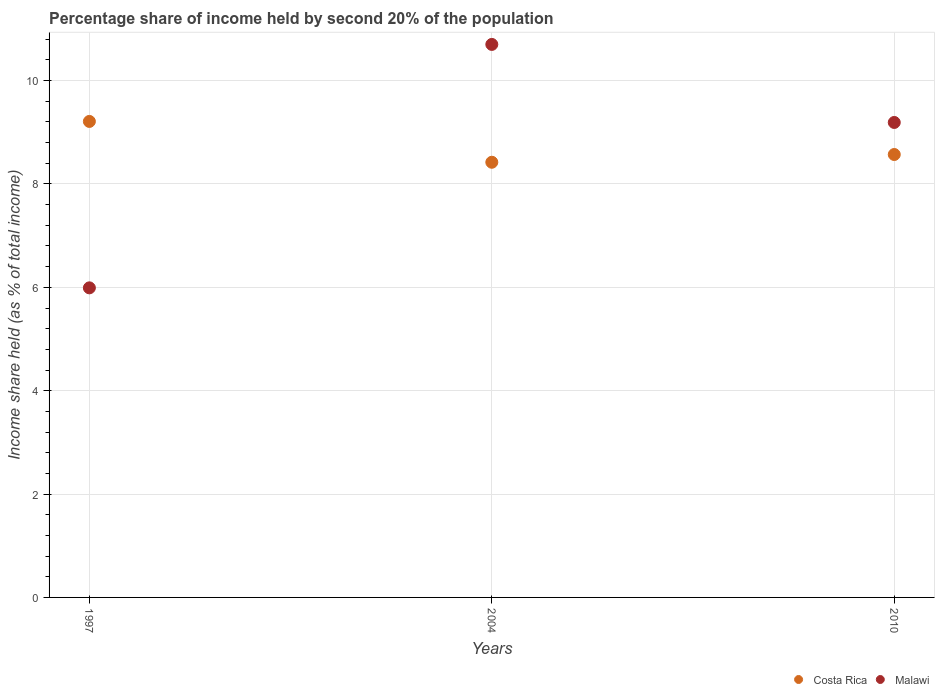Is the number of dotlines equal to the number of legend labels?
Make the answer very short. Yes. What is the share of income held by second 20% of the population in Malawi in 2010?
Give a very brief answer. 9.19. Across all years, what is the minimum share of income held by second 20% of the population in Malawi?
Offer a terse response. 5.99. What is the total share of income held by second 20% of the population in Malawi in the graph?
Give a very brief answer. 25.88. What is the difference between the share of income held by second 20% of the population in Malawi in 2004 and that in 2010?
Your response must be concise. 1.51. What is the difference between the share of income held by second 20% of the population in Malawi in 2004 and the share of income held by second 20% of the population in Costa Rica in 1997?
Your answer should be very brief. 1.49. What is the average share of income held by second 20% of the population in Malawi per year?
Provide a succinct answer. 8.63. In the year 1997, what is the difference between the share of income held by second 20% of the population in Costa Rica and share of income held by second 20% of the population in Malawi?
Provide a short and direct response. 3.22. What is the ratio of the share of income held by second 20% of the population in Costa Rica in 1997 to that in 2010?
Ensure brevity in your answer.  1.07. Is the share of income held by second 20% of the population in Malawi in 1997 less than that in 2010?
Give a very brief answer. Yes. Is the difference between the share of income held by second 20% of the population in Costa Rica in 2004 and 2010 greater than the difference between the share of income held by second 20% of the population in Malawi in 2004 and 2010?
Keep it short and to the point. No. What is the difference between the highest and the second highest share of income held by second 20% of the population in Malawi?
Your response must be concise. 1.51. What is the difference between the highest and the lowest share of income held by second 20% of the population in Costa Rica?
Ensure brevity in your answer.  0.79. Is the share of income held by second 20% of the population in Costa Rica strictly greater than the share of income held by second 20% of the population in Malawi over the years?
Make the answer very short. No. How many years are there in the graph?
Your response must be concise. 3. What is the difference between two consecutive major ticks on the Y-axis?
Keep it short and to the point. 2. Does the graph contain grids?
Offer a very short reply. Yes. Where does the legend appear in the graph?
Ensure brevity in your answer.  Bottom right. How many legend labels are there?
Your answer should be very brief. 2. What is the title of the graph?
Keep it short and to the point. Percentage share of income held by second 20% of the population. Does "Central African Republic" appear as one of the legend labels in the graph?
Offer a terse response. No. What is the label or title of the Y-axis?
Offer a very short reply. Income share held (as % of total income). What is the Income share held (as % of total income) in Costa Rica in 1997?
Ensure brevity in your answer.  9.21. What is the Income share held (as % of total income) in Malawi in 1997?
Ensure brevity in your answer.  5.99. What is the Income share held (as % of total income) of Costa Rica in 2004?
Offer a very short reply. 8.42. What is the Income share held (as % of total income) of Malawi in 2004?
Make the answer very short. 10.7. What is the Income share held (as % of total income) in Costa Rica in 2010?
Your answer should be compact. 8.57. What is the Income share held (as % of total income) in Malawi in 2010?
Give a very brief answer. 9.19. Across all years, what is the maximum Income share held (as % of total income) in Costa Rica?
Your answer should be very brief. 9.21. Across all years, what is the maximum Income share held (as % of total income) of Malawi?
Make the answer very short. 10.7. Across all years, what is the minimum Income share held (as % of total income) in Costa Rica?
Your response must be concise. 8.42. Across all years, what is the minimum Income share held (as % of total income) of Malawi?
Provide a succinct answer. 5.99. What is the total Income share held (as % of total income) in Costa Rica in the graph?
Provide a short and direct response. 26.2. What is the total Income share held (as % of total income) in Malawi in the graph?
Offer a terse response. 25.88. What is the difference between the Income share held (as % of total income) in Costa Rica in 1997 and that in 2004?
Ensure brevity in your answer.  0.79. What is the difference between the Income share held (as % of total income) of Malawi in 1997 and that in 2004?
Your answer should be compact. -4.71. What is the difference between the Income share held (as % of total income) in Costa Rica in 1997 and that in 2010?
Provide a succinct answer. 0.64. What is the difference between the Income share held (as % of total income) of Malawi in 2004 and that in 2010?
Your response must be concise. 1.51. What is the difference between the Income share held (as % of total income) of Costa Rica in 1997 and the Income share held (as % of total income) of Malawi in 2004?
Your response must be concise. -1.49. What is the difference between the Income share held (as % of total income) of Costa Rica in 2004 and the Income share held (as % of total income) of Malawi in 2010?
Keep it short and to the point. -0.77. What is the average Income share held (as % of total income) in Costa Rica per year?
Keep it short and to the point. 8.73. What is the average Income share held (as % of total income) of Malawi per year?
Make the answer very short. 8.63. In the year 1997, what is the difference between the Income share held (as % of total income) in Costa Rica and Income share held (as % of total income) in Malawi?
Keep it short and to the point. 3.22. In the year 2004, what is the difference between the Income share held (as % of total income) in Costa Rica and Income share held (as % of total income) in Malawi?
Offer a terse response. -2.28. In the year 2010, what is the difference between the Income share held (as % of total income) in Costa Rica and Income share held (as % of total income) in Malawi?
Keep it short and to the point. -0.62. What is the ratio of the Income share held (as % of total income) in Costa Rica in 1997 to that in 2004?
Your answer should be compact. 1.09. What is the ratio of the Income share held (as % of total income) in Malawi in 1997 to that in 2004?
Make the answer very short. 0.56. What is the ratio of the Income share held (as % of total income) of Costa Rica in 1997 to that in 2010?
Ensure brevity in your answer.  1.07. What is the ratio of the Income share held (as % of total income) of Malawi in 1997 to that in 2010?
Give a very brief answer. 0.65. What is the ratio of the Income share held (as % of total income) in Costa Rica in 2004 to that in 2010?
Provide a succinct answer. 0.98. What is the ratio of the Income share held (as % of total income) of Malawi in 2004 to that in 2010?
Ensure brevity in your answer.  1.16. What is the difference between the highest and the second highest Income share held (as % of total income) of Costa Rica?
Your answer should be compact. 0.64. What is the difference between the highest and the second highest Income share held (as % of total income) of Malawi?
Provide a short and direct response. 1.51. What is the difference between the highest and the lowest Income share held (as % of total income) of Costa Rica?
Your answer should be very brief. 0.79. What is the difference between the highest and the lowest Income share held (as % of total income) in Malawi?
Provide a succinct answer. 4.71. 